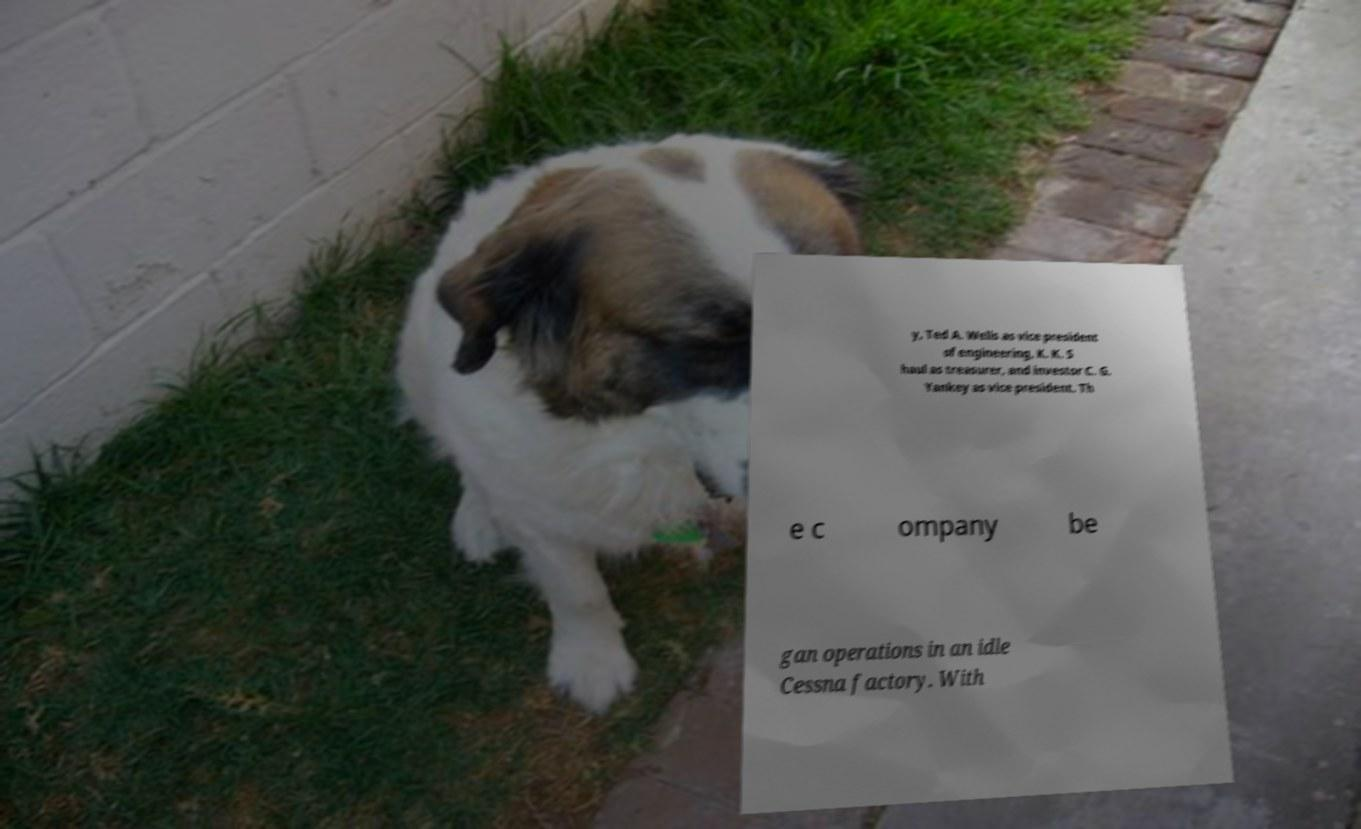For documentation purposes, I need the text within this image transcribed. Could you provide that? y, Ted A. Wells as vice president of engineering, K. K. S haul as treasurer, and investor C. G. Yankey as vice president. Th e c ompany be gan operations in an idle Cessna factory. With 